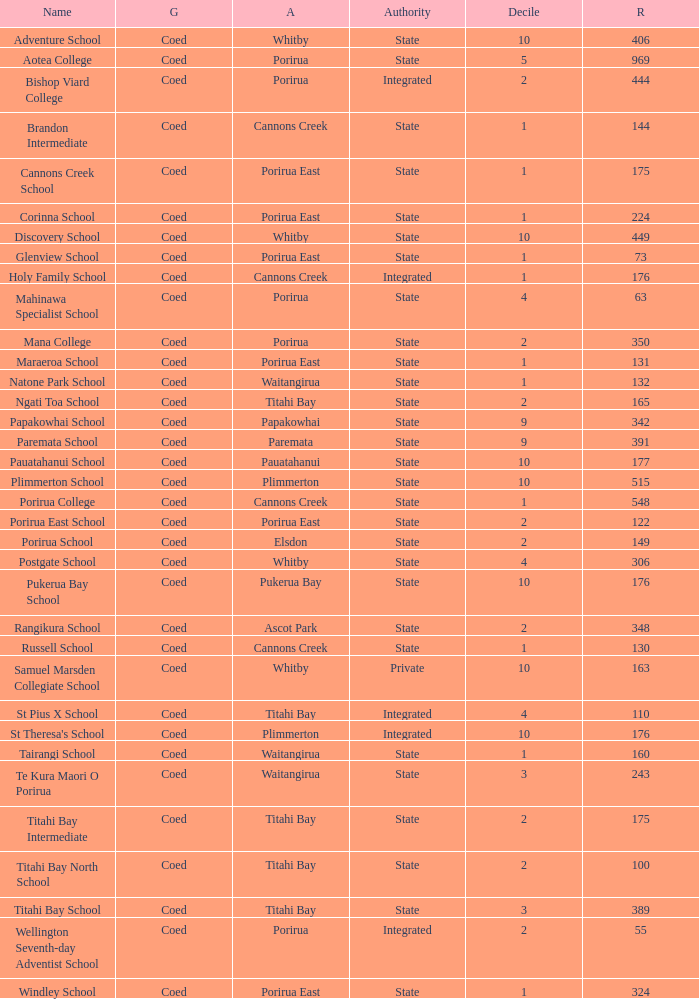What integrated school had a decile of 2 and a roll larger than 55? Bishop Viard College. 